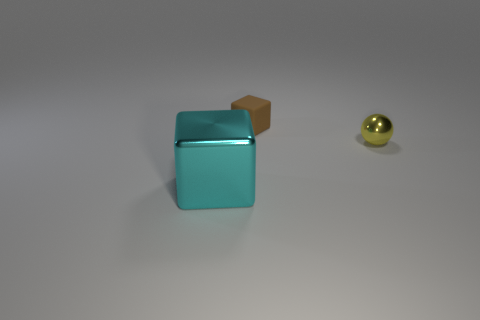Subtract all cyan cubes. Subtract all cyan cylinders. How many cubes are left? 1 Subtract all yellow cubes. How many purple spheres are left? 0 Add 2 reds. How many small objects exist? 0 Subtract all tiny yellow things. Subtract all metallic objects. How many objects are left? 0 Add 1 tiny brown rubber things. How many tiny brown rubber things are left? 2 Add 3 small rubber objects. How many small rubber objects exist? 4 Add 2 yellow shiny spheres. How many objects exist? 5 Subtract all cyan blocks. How many blocks are left? 1 Subtract 0 cyan spheres. How many objects are left? 3 Subtract all blocks. How many objects are left? 1 